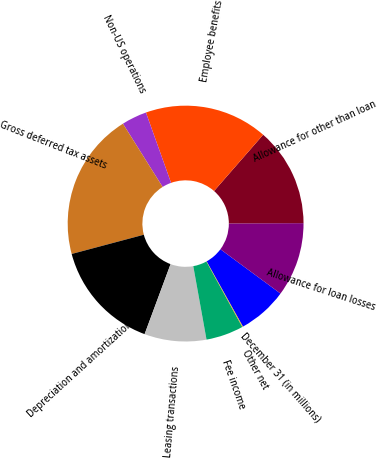Convert chart to OTSL. <chart><loc_0><loc_0><loc_500><loc_500><pie_chart><fcel>December 31 (in millions)<fcel>Allowance for loan losses<fcel>Allowance for other than loan<fcel>Employee benefits<fcel>Non-US operations<fcel>Gross deferred tax assets<fcel>Depreciation and amortization<fcel>Leasing transactions<fcel>Fee income<fcel>Other net<nl><fcel>6.81%<fcel>10.17%<fcel>13.52%<fcel>16.88%<fcel>3.46%<fcel>20.23%<fcel>15.2%<fcel>8.49%<fcel>5.14%<fcel>0.1%<nl></chart> 